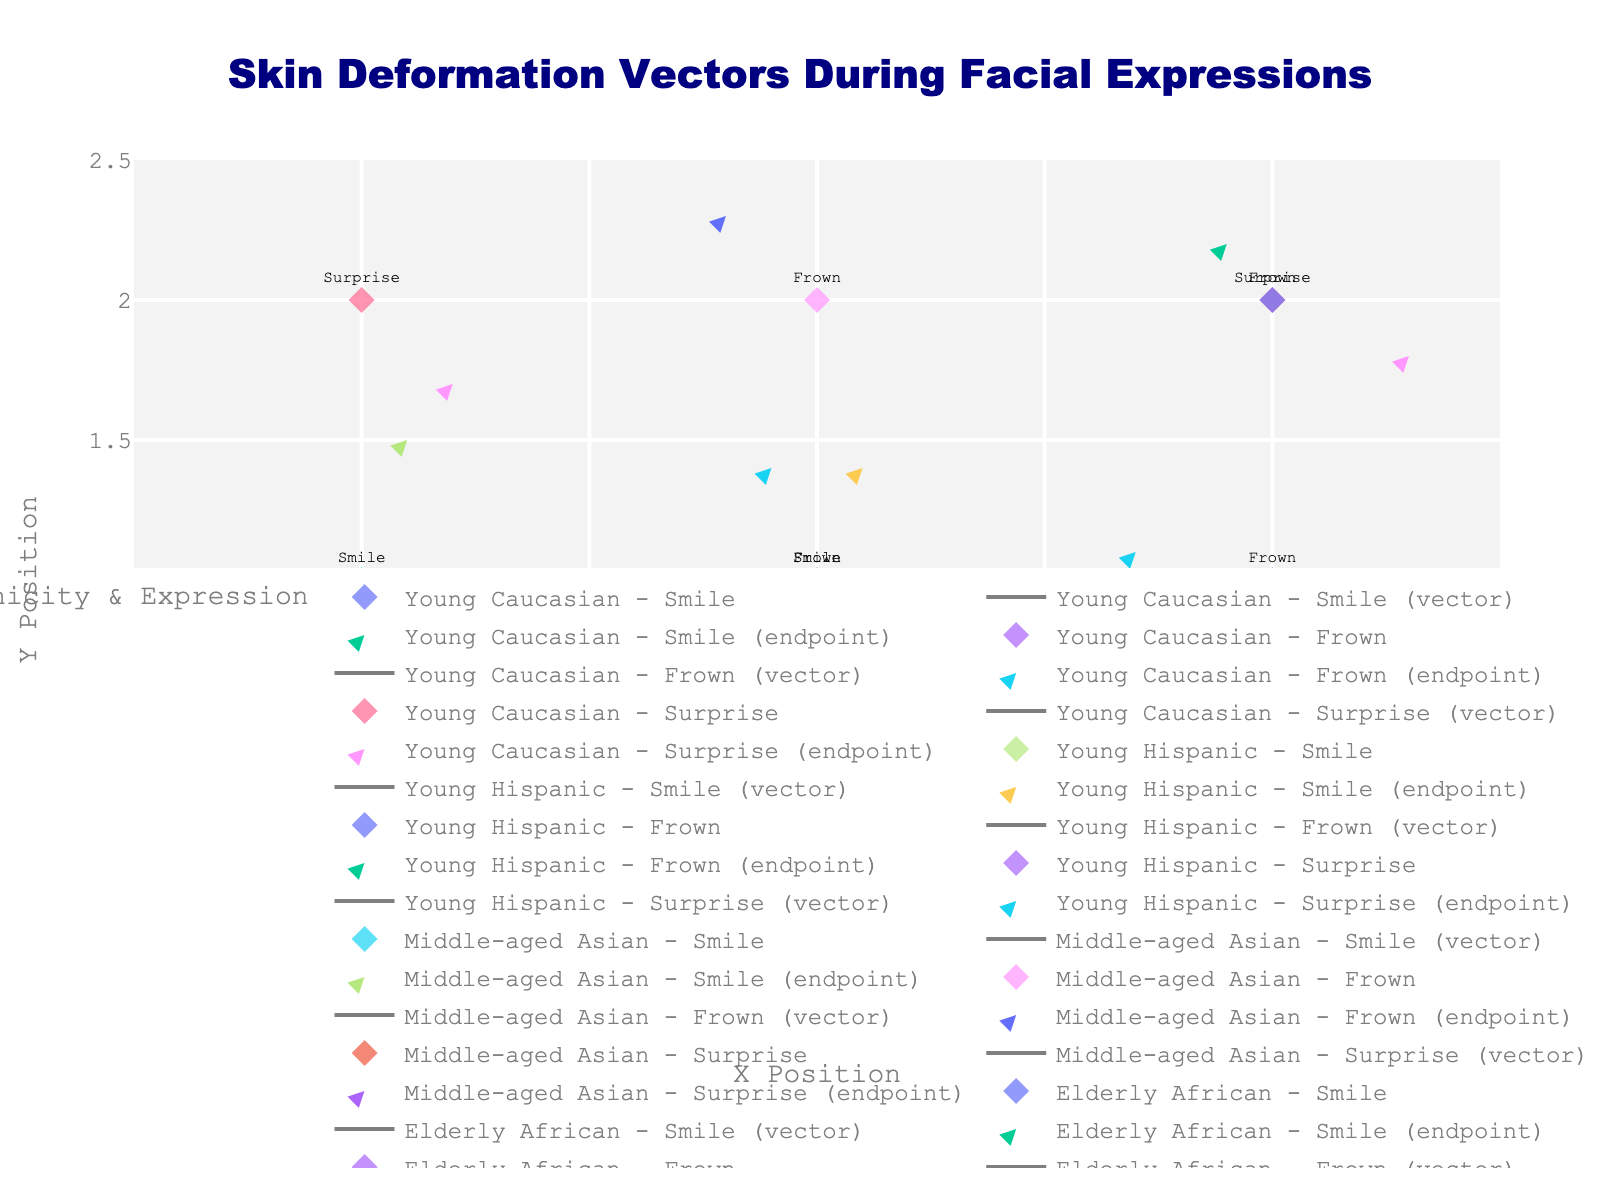What is the title of the plot? The title is typically located at the top of the plot and provides a summary of the visual content.
Answer: Skin Deformation Vectors During Facial Expressions How many age groups are represented in the plot? The different age groups can be identified by examining the legend in the plot. Each age group has distinct entries.
Answer: 3 Which ethnicity has the most data points for the 'Smile' expression? To find this, we need to count the data points for each ethnicity with the 'Smile' expression by looking for markers labeled with 'Smile' in the legend.
Answer: All have 1 data point each What is the x-coordinate of the endpoint for the 'Surprise' expression in the Young Hispanic group? Locate the 'Young Hispanic - Surprise' in the legend, and then find the endpoint of the vector associated with it by adding the 'u' value to the 'x' initial value.
Answer: 0.3 Compare the magnitude of the deformation vectors for 'Smile' between Young Caucasian and Elderly African groups. Which is larger? Calculate the magnitude for both groups using the formula sqrt(u^2 + v^2) for their respective (u, v) values. The larger magnitude corresponds to the group with the greater deformation vector.
Answer: Young Caucasian For the 'Frown' expression in Middle-aged Asian and Elderly African groups, which has a greater vertical deformation? Compare the v components of the vectors for 'Frown' in both groups. The one with the larger absolute value of v has a greater vertical deformation.
Answer: Middle-aged Asian How many data points have vectors pointing to the right (positive u value)? Count the data points where the u value is positive, which indicates the vector points to the right.
Answer: 5 Which age group and ethnicity combination displays the least skin deformation during 'Surprise'? Calculate the magnitude of deformation vectors for 'Surprise' across all age and ethnicity combinations, and identify the smallest one.
Answer: Elderly African Compare the horizontal deformation (u values) for 'Smile' between Young Caucasians and Middle-aged Asians. Which has a larger horizontal deformation? Compare the u values for 'Smile' in both groups. The one with the larger absolute value of u has a larger horizontal deformation.
Answer: Young Caucasians What is the average vertical deformation (v values) of all 'Frown' expressions? Sum the v values for 'Frown' across all data points and divide by the number of 'Frown' expressions to get the average.
Answer: 0.25 